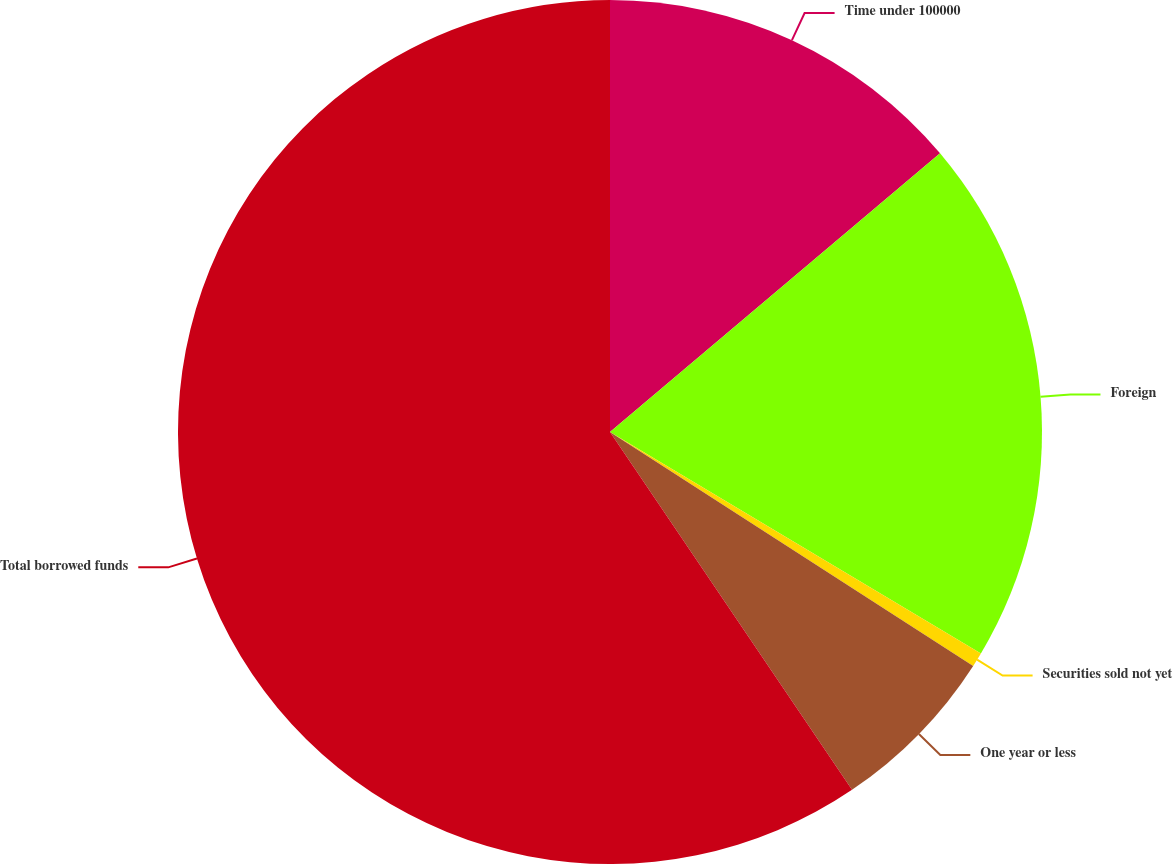<chart> <loc_0><loc_0><loc_500><loc_500><pie_chart><fcel>Time under 100000<fcel>Foreign<fcel>Securities sold not yet<fcel>One year or less<fcel>Total borrowed funds<nl><fcel>13.84%<fcel>19.73%<fcel>0.54%<fcel>6.43%<fcel>59.47%<nl></chart> 